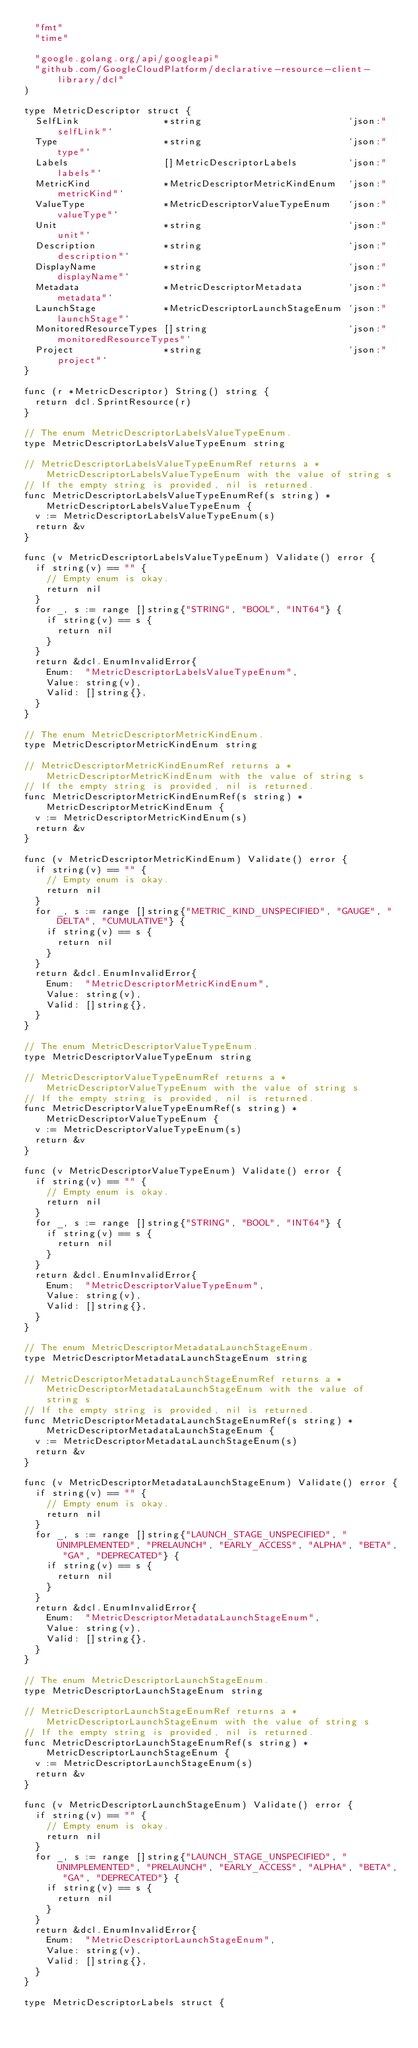<code> <loc_0><loc_0><loc_500><loc_500><_Go_>	"fmt"
	"time"

	"google.golang.org/api/googleapi"
	"github.com/GoogleCloudPlatform/declarative-resource-client-library/dcl"
)

type MetricDescriptor struct {
	SelfLink               *string                          `json:"selfLink"`
	Type                   *string                          `json:"type"`
	Labels                 []MetricDescriptorLabels         `json:"labels"`
	MetricKind             *MetricDescriptorMetricKindEnum  `json:"metricKind"`
	ValueType              *MetricDescriptorValueTypeEnum   `json:"valueType"`
	Unit                   *string                          `json:"unit"`
	Description            *string                          `json:"description"`
	DisplayName            *string                          `json:"displayName"`
	Metadata               *MetricDescriptorMetadata        `json:"metadata"`
	LaunchStage            *MetricDescriptorLaunchStageEnum `json:"launchStage"`
	MonitoredResourceTypes []string                         `json:"monitoredResourceTypes"`
	Project                *string                          `json:"project"`
}

func (r *MetricDescriptor) String() string {
	return dcl.SprintResource(r)
}

// The enum MetricDescriptorLabelsValueTypeEnum.
type MetricDescriptorLabelsValueTypeEnum string

// MetricDescriptorLabelsValueTypeEnumRef returns a *MetricDescriptorLabelsValueTypeEnum with the value of string s
// If the empty string is provided, nil is returned.
func MetricDescriptorLabelsValueTypeEnumRef(s string) *MetricDescriptorLabelsValueTypeEnum {
	v := MetricDescriptorLabelsValueTypeEnum(s)
	return &v
}

func (v MetricDescriptorLabelsValueTypeEnum) Validate() error {
	if string(v) == "" {
		// Empty enum is okay.
		return nil
	}
	for _, s := range []string{"STRING", "BOOL", "INT64"} {
		if string(v) == s {
			return nil
		}
	}
	return &dcl.EnumInvalidError{
		Enum:  "MetricDescriptorLabelsValueTypeEnum",
		Value: string(v),
		Valid: []string{},
	}
}

// The enum MetricDescriptorMetricKindEnum.
type MetricDescriptorMetricKindEnum string

// MetricDescriptorMetricKindEnumRef returns a *MetricDescriptorMetricKindEnum with the value of string s
// If the empty string is provided, nil is returned.
func MetricDescriptorMetricKindEnumRef(s string) *MetricDescriptorMetricKindEnum {
	v := MetricDescriptorMetricKindEnum(s)
	return &v
}

func (v MetricDescriptorMetricKindEnum) Validate() error {
	if string(v) == "" {
		// Empty enum is okay.
		return nil
	}
	for _, s := range []string{"METRIC_KIND_UNSPECIFIED", "GAUGE", "DELTA", "CUMULATIVE"} {
		if string(v) == s {
			return nil
		}
	}
	return &dcl.EnumInvalidError{
		Enum:  "MetricDescriptorMetricKindEnum",
		Value: string(v),
		Valid: []string{},
	}
}

// The enum MetricDescriptorValueTypeEnum.
type MetricDescriptorValueTypeEnum string

// MetricDescriptorValueTypeEnumRef returns a *MetricDescriptorValueTypeEnum with the value of string s
// If the empty string is provided, nil is returned.
func MetricDescriptorValueTypeEnumRef(s string) *MetricDescriptorValueTypeEnum {
	v := MetricDescriptorValueTypeEnum(s)
	return &v
}

func (v MetricDescriptorValueTypeEnum) Validate() error {
	if string(v) == "" {
		// Empty enum is okay.
		return nil
	}
	for _, s := range []string{"STRING", "BOOL", "INT64"} {
		if string(v) == s {
			return nil
		}
	}
	return &dcl.EnumInvalidError{
		Enum:  "MetricDescriptorValueTypeEnum",
		Value: string(v),
		Valid: []string{},
	}
}

// The enum MetricDescriptorMetadataLaunchStageEnum.
type MetricDescriptorMetadataLaunchStageEnum string

// MetricDescriptorMetadataLaunchStageEnumRef returns a *MetricDescriptorMetadataLaunchStageEnum with the value of string s
// If the empty string is provided, nil is returned.
func MetricDescriptorMetadataLaunchStageEnumRef(s string) *MetricDescriptorMetadataLaunchStageEnum {
	v := MetricDescriptorMetadataLaunchStageEnum(s)
	return &v
}

func (v MetricDescriptorMetadataLaunchStageEnum) Validate() error {
	if string(v) == "" {
		// Empty enum is okay.
		return nil
	}
	for _, s := range []string{"LAUNCH_STAGE_UNSPECIFIED", "UNIMPLEMENTED", "PRELAUNCH", "EARLY_ACCESS", "ALPHA", "BETA", "GA", "DEPRECATED"} {
		if string(v) == s {
			return nil
		}
	}
	return &dcl.EnumInvalidError{
		Enum:  "MetricDescriptorMetadataLaunchStageEnum",
		Value: string(v),
		Valid: []string{},
	}
}

// The enum MetricDescriptorLaunchStageEnum.
type MetricDescriptorLaunchStageEnum string

// MetricDescriptorLaunchStageEnumRef returns a *MetricDescriptorLaunchStageEnum with the value of string s
// If the empty string is provided, nil is returned.
func MetricDescriptorLaunchStageEnumRef(s string) *MetricDescriptorLaunchStageEnum {
	v := MetricDescriptorLaunchStageEnum(s)
	return &v
}

func (v MetricDescriptorLaunchStageEnum) Validate() error {
	if string(v) == "" {
		// Empty enum is okay.
		return nil
	}
	for _, s := range []string{"LAUNCH_STAGE_UNSPECIFIED", "UNIMPLEMENTED", "PRELAUNCH", "EARLY_ACCESS", "ALPHA", "BETA", "GA", "DEPRECATED"} {
		if string(v) == s {
			return nil
		}
	}
	return &dcl.EnumInvalidError{
		Enum:  "MetricDescriptorLaunchStageEnum",
		Value: string(v),
		Valid: []string{},
	}
}

type MetricDescriptorLabels struct {</code> 